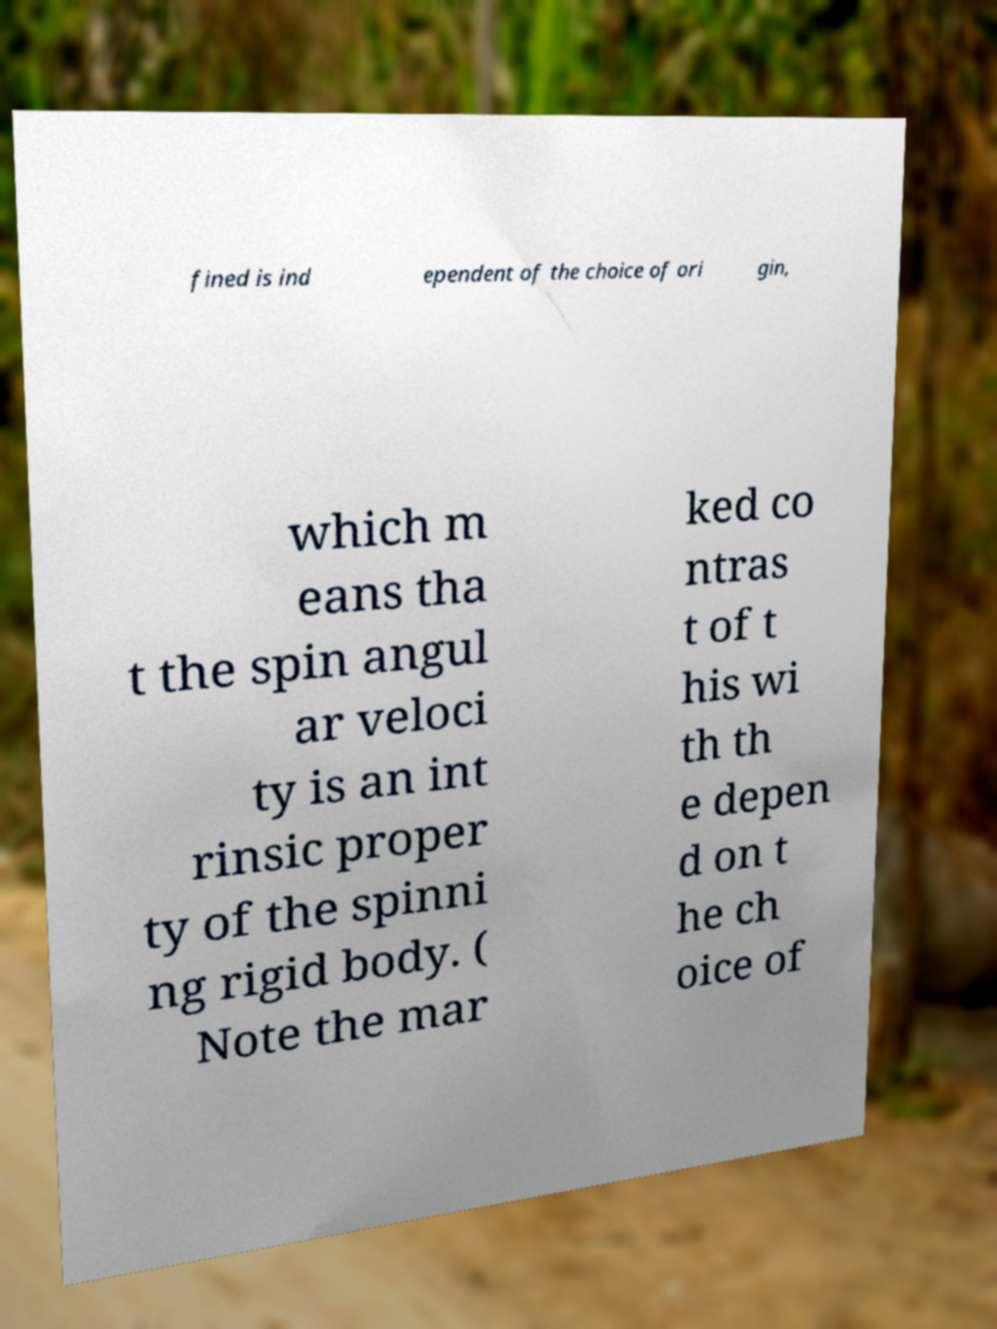I need the written content from this picture converted into text. Can you do that? fined is ind ependent of the choice of ori gin, which m eans tha t the spin angul ar veloci ty is an int rinsic proper ty of the spinni ng rigid body. ( Note the mar ked co ntras t of t his wi th th e depen d on t he ch oice of 